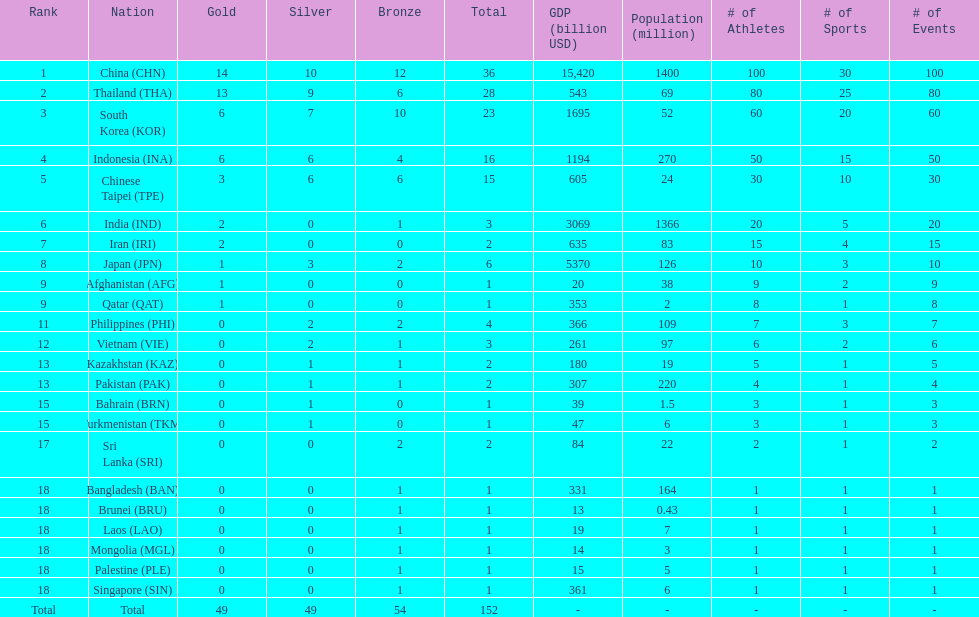Could you help me parse every detail presented in this table? {'header': ['Rank', 'Nation', 'Gold', 'Silver', 'Bronze', 'Total', 'GDP (billion USD)', 'Population (million)', '# of Athletes', '# of Sports', '# of Events'], 'rows': [['1', 'China\xa0(CHN)', '14', '10', '12', '36', '15,420', '1400', '100', '30', '100'], ['2', 'Thailand\xa0(THA)', '13', '9', '6', '28', '543', '69', '80', '25', '80'], ['3', 'South Korea\xa0(KOR)', '6', '7', '10', '23', '1695', '52', '60', '20', '60'], ['4', 'Indonesia\xa0(INA)', '6', '6', '4', '16', '1194', '270', '50', '15', '50'], ['5', 'Chinese Taipei\xa0(TPE)', '3', '6', '6', '15', '605', '24', '30', '10', '30'], ['6', 'India\xa0(IND)', '2', '0', '1', '3', '3069', '1366', '20', '5', '20'], ['7', 'Iran\xa0(IRI)', '2', '0', '0', '2', '635', '83', '15', '4', '15'], ['8', 'Japan\xa0(JPN)', '1', '3', '2', '6', '5370', '126', '10', '3', '10'], ['9', 'Afghanistan\xa0(AFG)', '1', '0', '0', '1', '20', '38', '9', '2', '9'], ['9', 'Qatar\xa0(QAT)', '1', '0', '0', '1', '353', '2', '8', '1', '8'], ['11', 'Philippines\xa0(PHI)', '0', '2', '2', '4', '366', '109', '7', '3', '7'], ['12', 'Vietnam\xa0(VIE)', '0', '2', '1', '3', '261', '97', '6', '2', '6'], ['13', 'Kazakhstan\xa0(KAZ)', '0', '1', '1', '2', '180', '19', '5', '1', '5'], ['13', 'Pakistan\xa0(PAK)', '0', '1', '1', '2', '307', '220', '4', '1', '4'], ['15', 'Bahrain\xa0(BRN)', '0', '1', '0', '1', '39', '1.5', '3', '1', '3'], ['15', 'Turkmenistan\xa0(TKM)', '0', '1', '0', '1', '47', '6', '3', '1', '3'], ['17', 'Sri Lanka\xa0(SRI)', '0', '0', '2', '2', '84', '22', '2', '1', '2'], ['18', 'Bangladesh\xa0(BAN)', '0', '0', '1', '1', '331', '164', '1', '1', '1'], ['18', 'Brunei\xa0(BRU)', '0', '0', '1', '1', '13', '0.43', '1', '1', '1'], ['18', 'Laos\xa0(LAO)', '0', '0', '1', '1', '19', '7', '1', '1', '1'], ['18', 'Mongolia\xa0(MGL)', '0', '0', '1', '1', '14', '3', '1', '1', '1'], ['18', 'Palestine\xa0(PLE)', '0', '0', '1', '1', '15', '5', '1', '1', '1'], ['18', 'Singapore\xa0(SIN)', '0', '0', '1', '1', '361', '6', '1', '1', '1'], ['Total', 'Total', '49', '49', '54', '152', '-', '-', '-', '-', '-']]} Which nation finished first in total medals earned? China (CHN). 